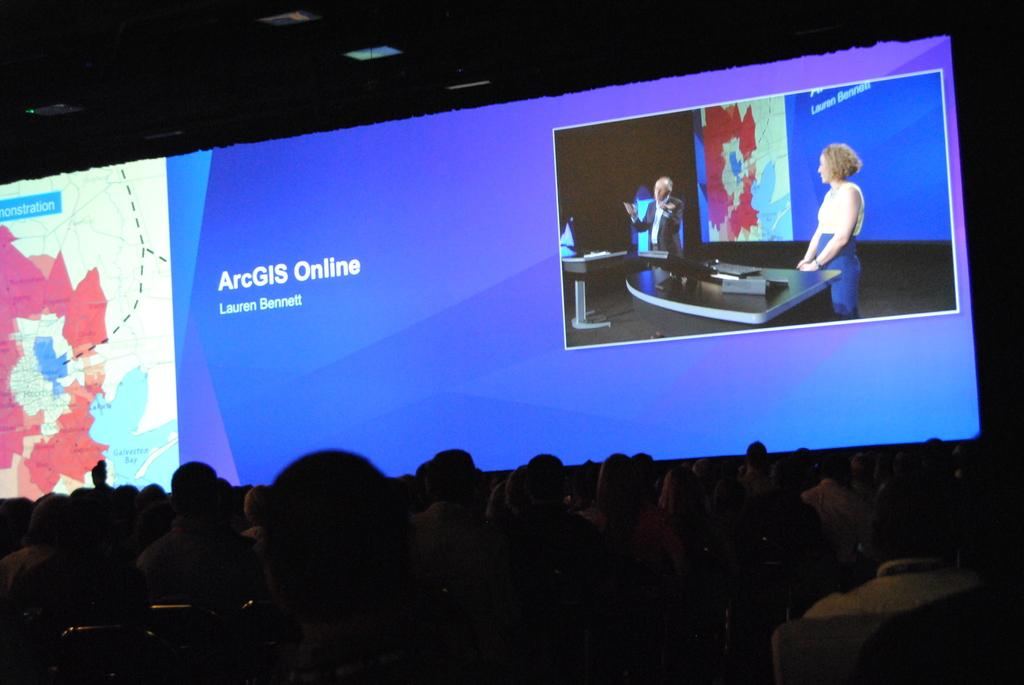<image>
Present a compact description of the photo's key features. A presentation for ArcGIS Online is shown a large widescreen. 